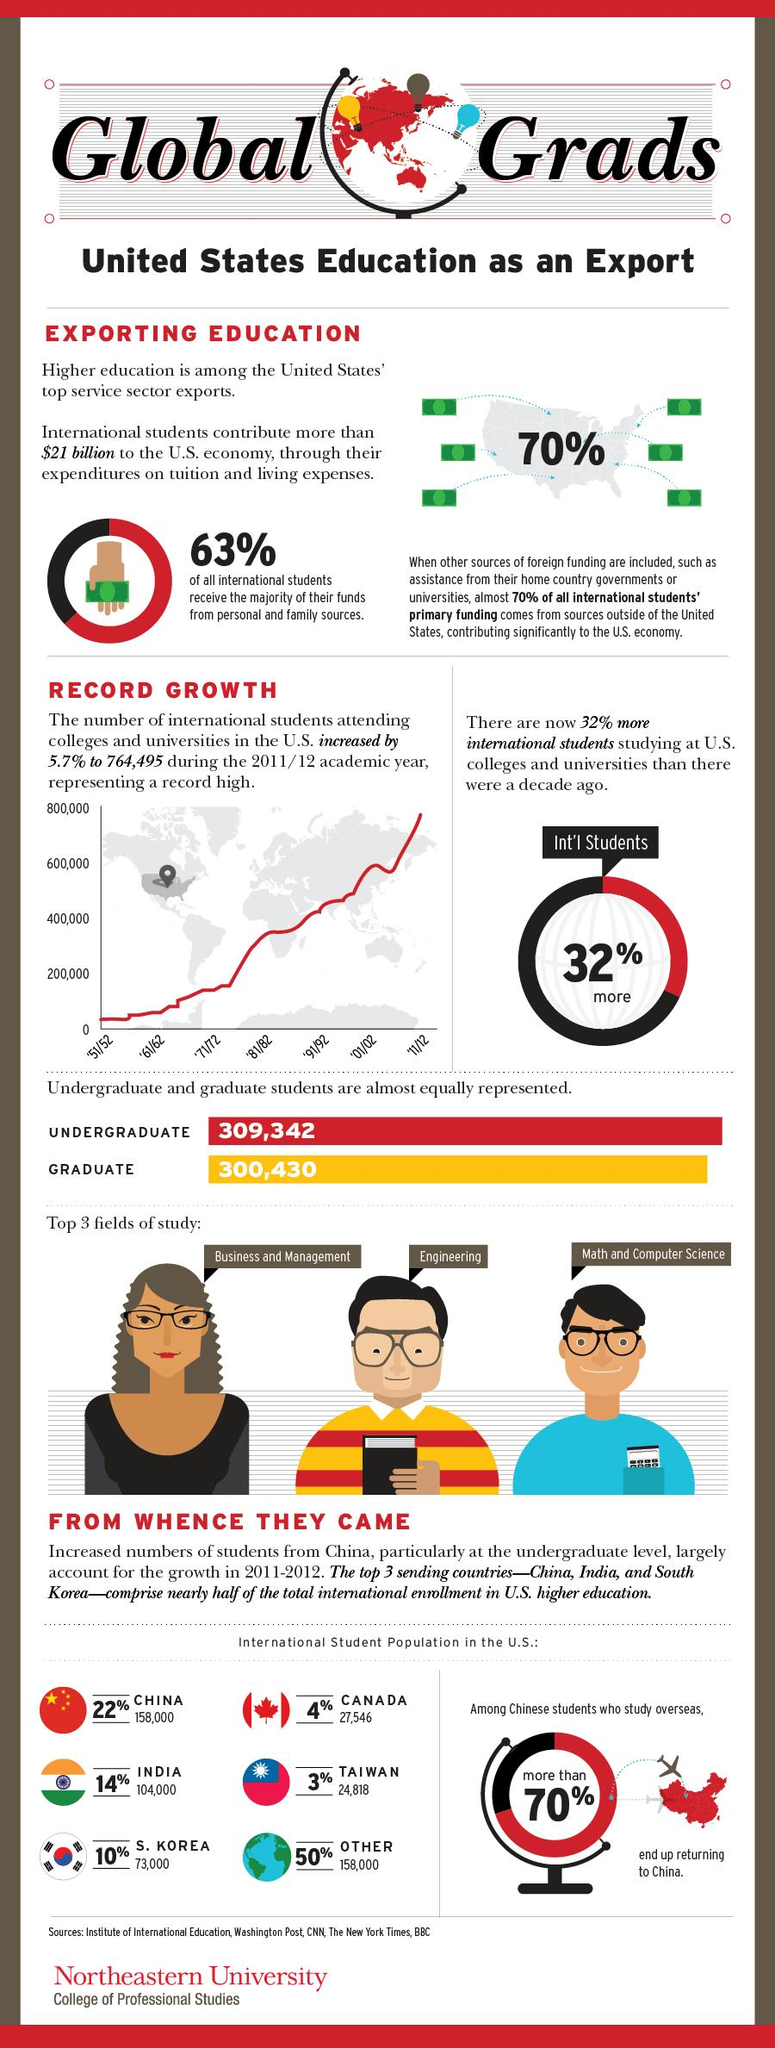List a handful of essential elements in this visual. The total percentage of international students from China and other countries is 72%. The countries that do not rank among the top three countries that send students for higher studies to the United States are Canada, Taiwan, and others. The difference between graduates and undergraduates represented in the data is 8,912. 